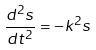<formula> <loc_0><loc_0><loc_500><loc_500>\frac { d ^ { 2 } s } { d t ^ { 2 } } = - k ^ { 2 } s</formula> 